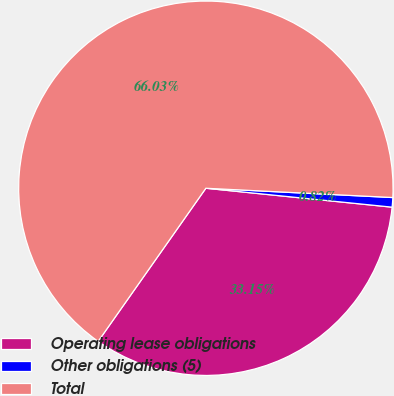Convert chart. <chart><loc_0><loc_0><loc_500><loc_500><pie_chart><fcel>Operating lease obligations<fcel>Other obligations (5)<fcel>Total<nl><fcel>33.15%<fcel>0.82%<fcel>66.04%<nl></chart> 